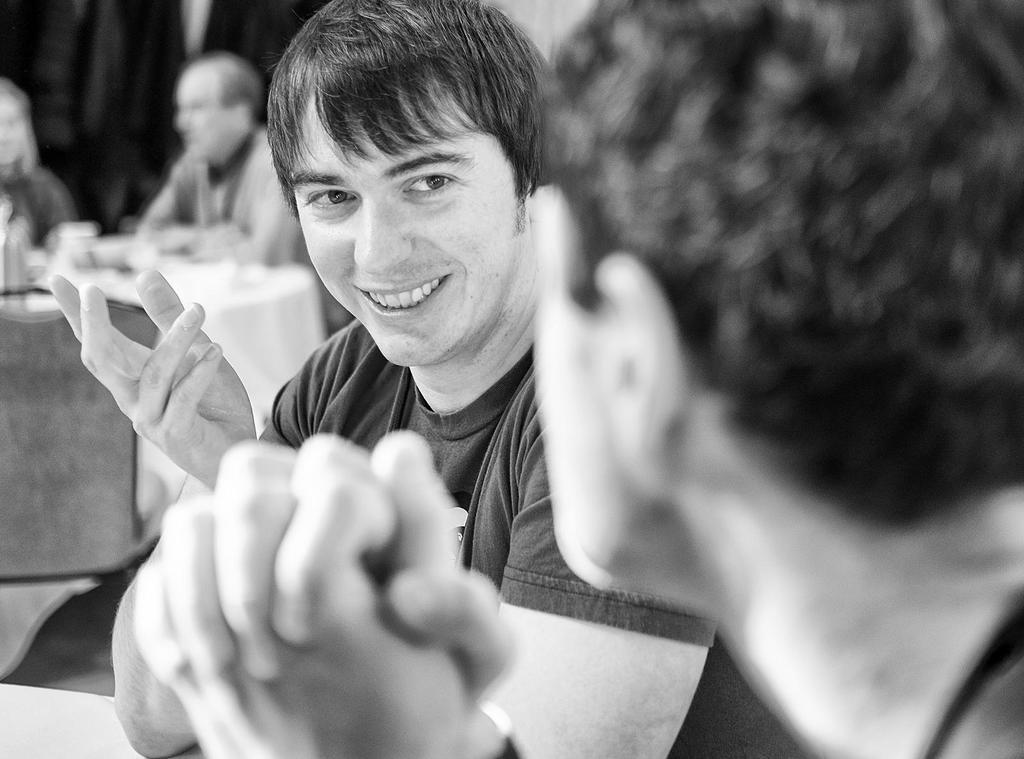Can you describe this image briefly? In this image there is a boys sitting on the chair, smiling and giving a pose into the camera. Behind there is dining table and a man and woman sitting and talking with each other. 